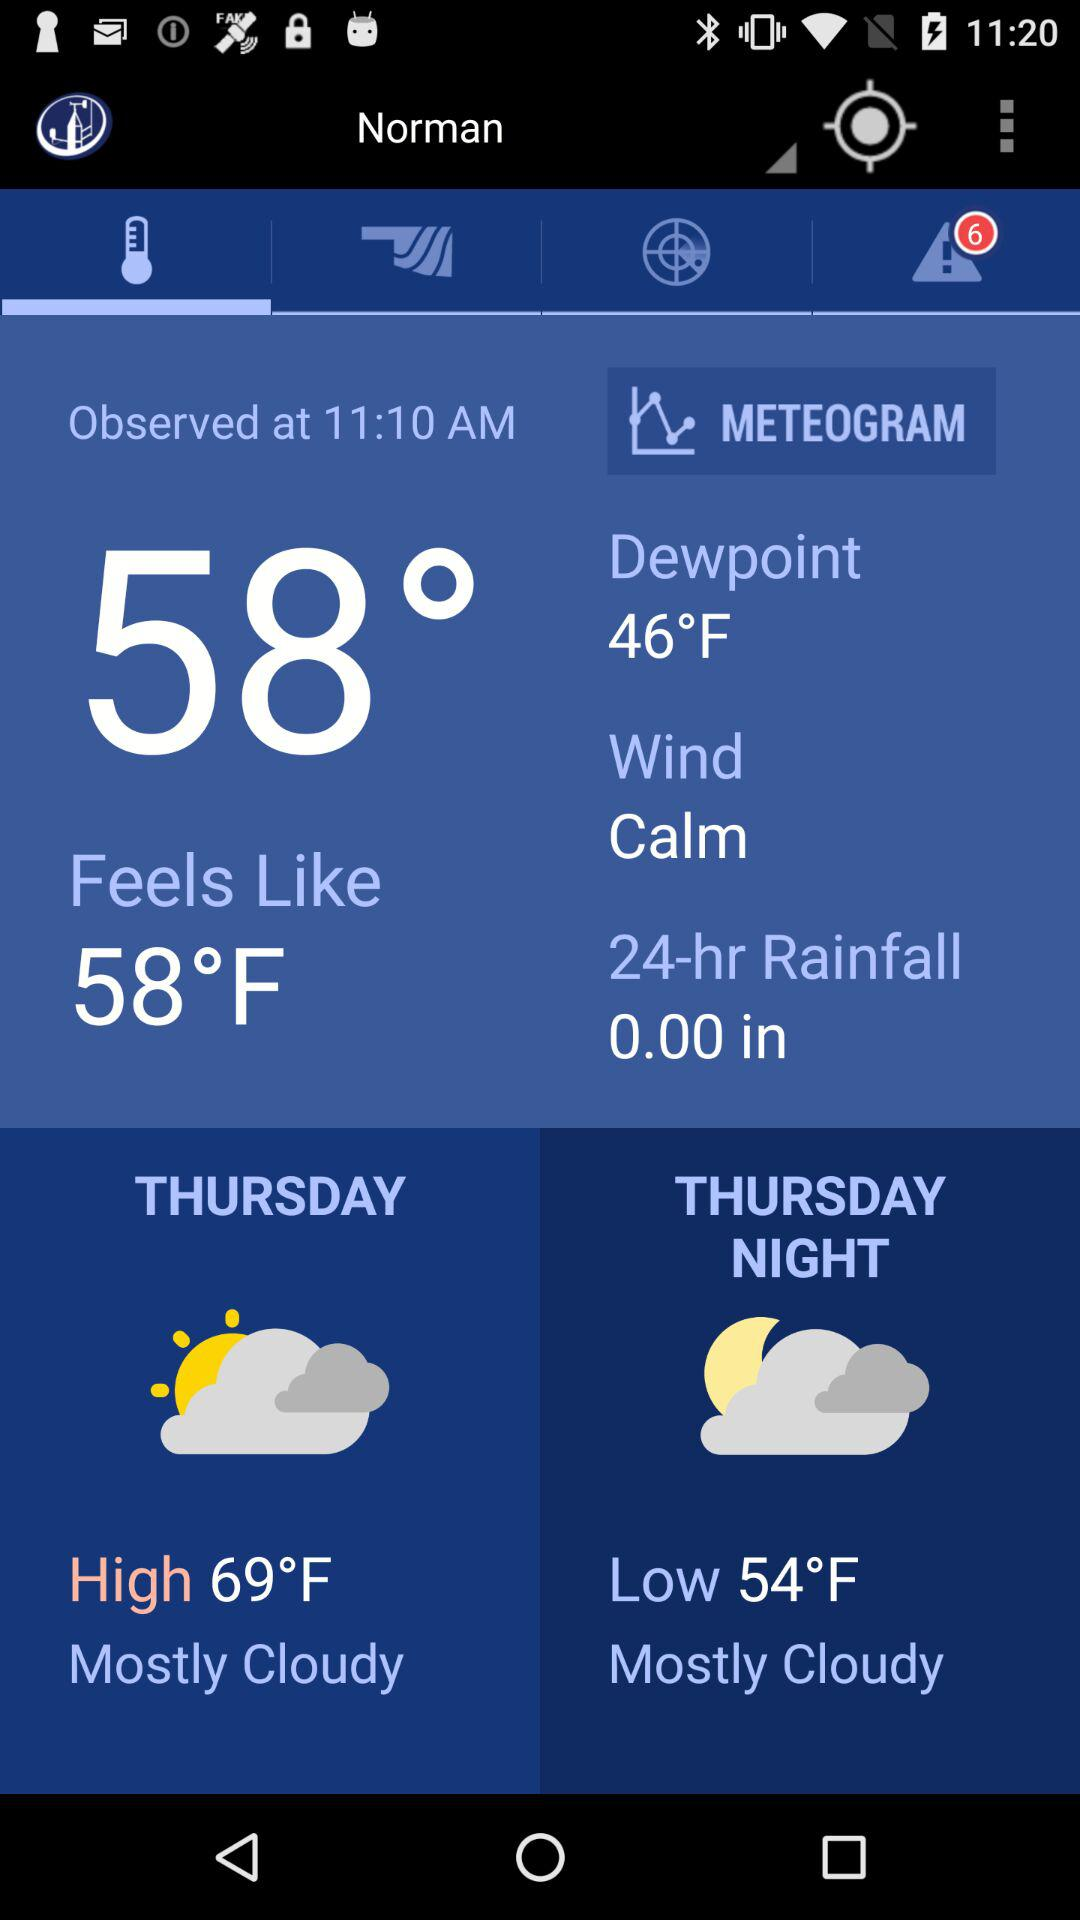What is the difference in temperature between the high and low temperatures for Thursday?
Answer the question using a single word or phrase. 15°F 